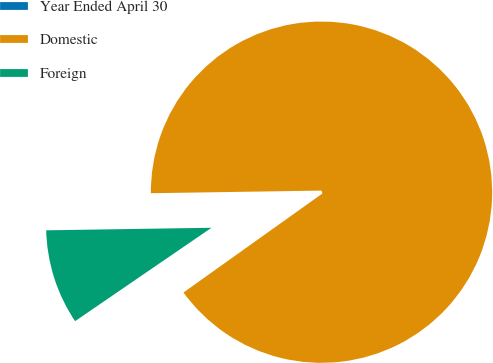<chart> <loc_0><loc_0><loc_500><loc_500><pie_chart><fcel>Year Ended April 30<fcel>Domestic<fcel>Foreign<nl><fcel>0.3%<fcel>90.39%<fcel>9.31%<nl></chart> 